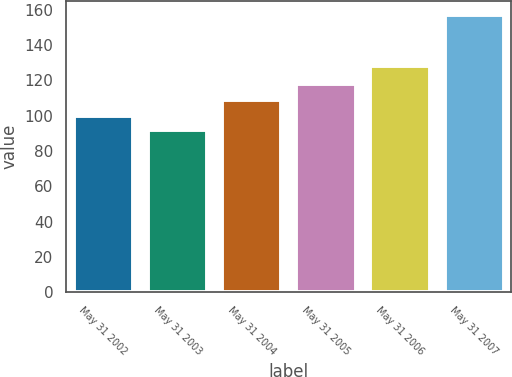Convert chart to OTSL. <chart><loc_0><loc_0><loc_500><loc_500><bar_chart><fcel>May 31 2002<fcel>May 31 2003<fcel>May 31 2004<fcel>May 31 2005<fcel>May 31 2006<fcel>May 31 2007<nl><fcel>100<fcel>91.94<fcel>108.79<fcel>117.75<fcel>127.92<fcel>157.08<nl></chart> 